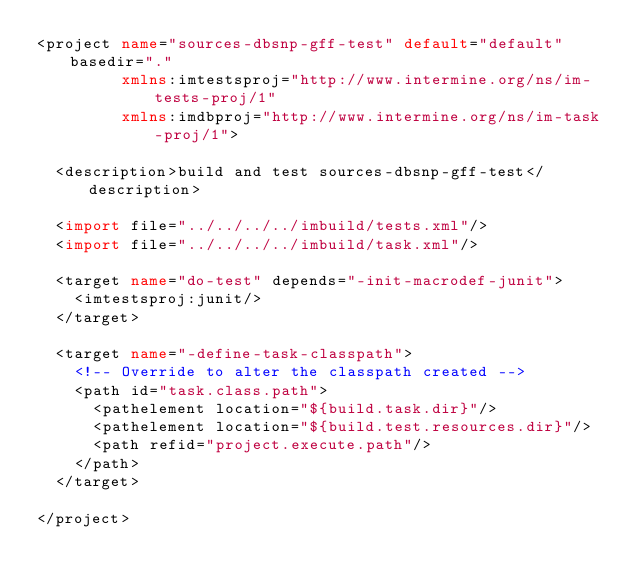Convert code to text. <code><loc_0><loc_0><loc_500><loc_500><_XML_><project name="sources-dbsnp-gff-test" default="default" basedir="."
         xmlns:imtestsproj="http://www.intermine.org/ns/im-tests-proj/1"
         xmlns:imdbproj="http://www.intermine.org/ns/im-task-proj/1">

  <description>build and test sources-dbsnp-gff-test</description>

  <import file="../../../../imbuild/tests.xml"/>
  <import file="../../../../imbuild/task.xml"/>

  <target name="do-test" depends="-init-macrodef-junit">
    <imtestsproj:junit/>
  </target>

  <target name="-define-task-classpath">
    <!-- Override to alter the classpath created -->
    <path id="task.class.path">
      <pathelement location="${build.task.dir}"/>
      <pathelement location="${build.test.resources.dir}"/>
      <path refid="project.execute.path"/>
    </path>
  </target>

</project>
</code> 